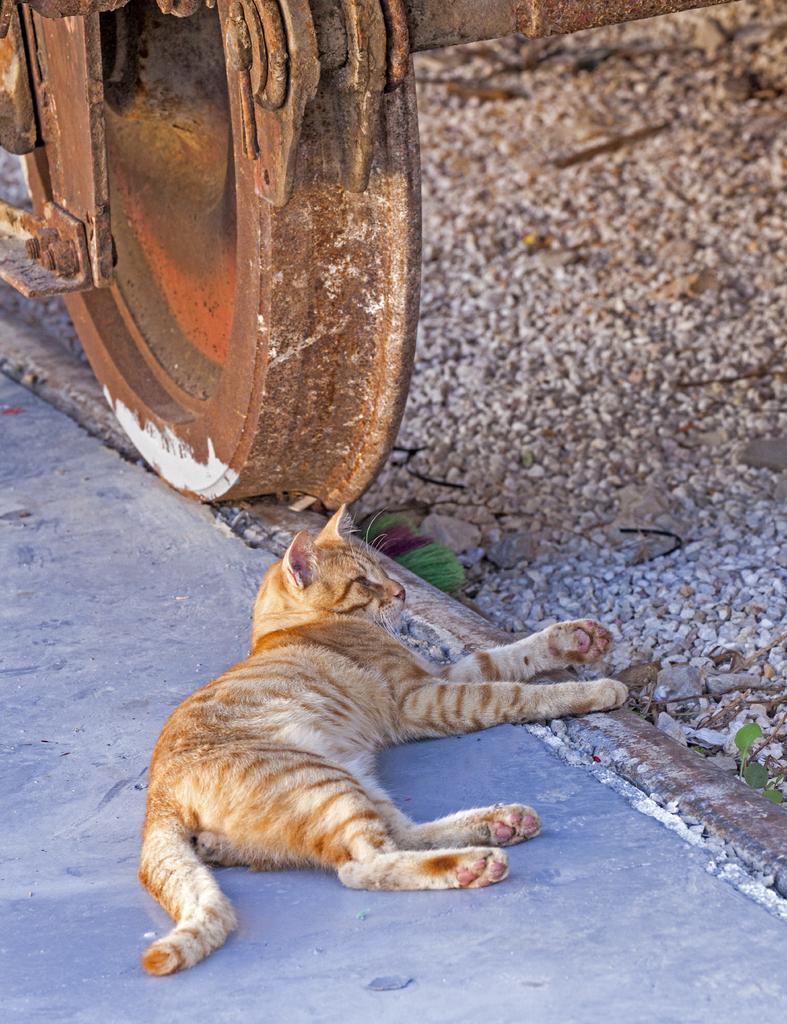Please provide a concise description of this image. In this picture we can see a cat lying here, on the right side there are some stones, we can see a wheel of a train here. 